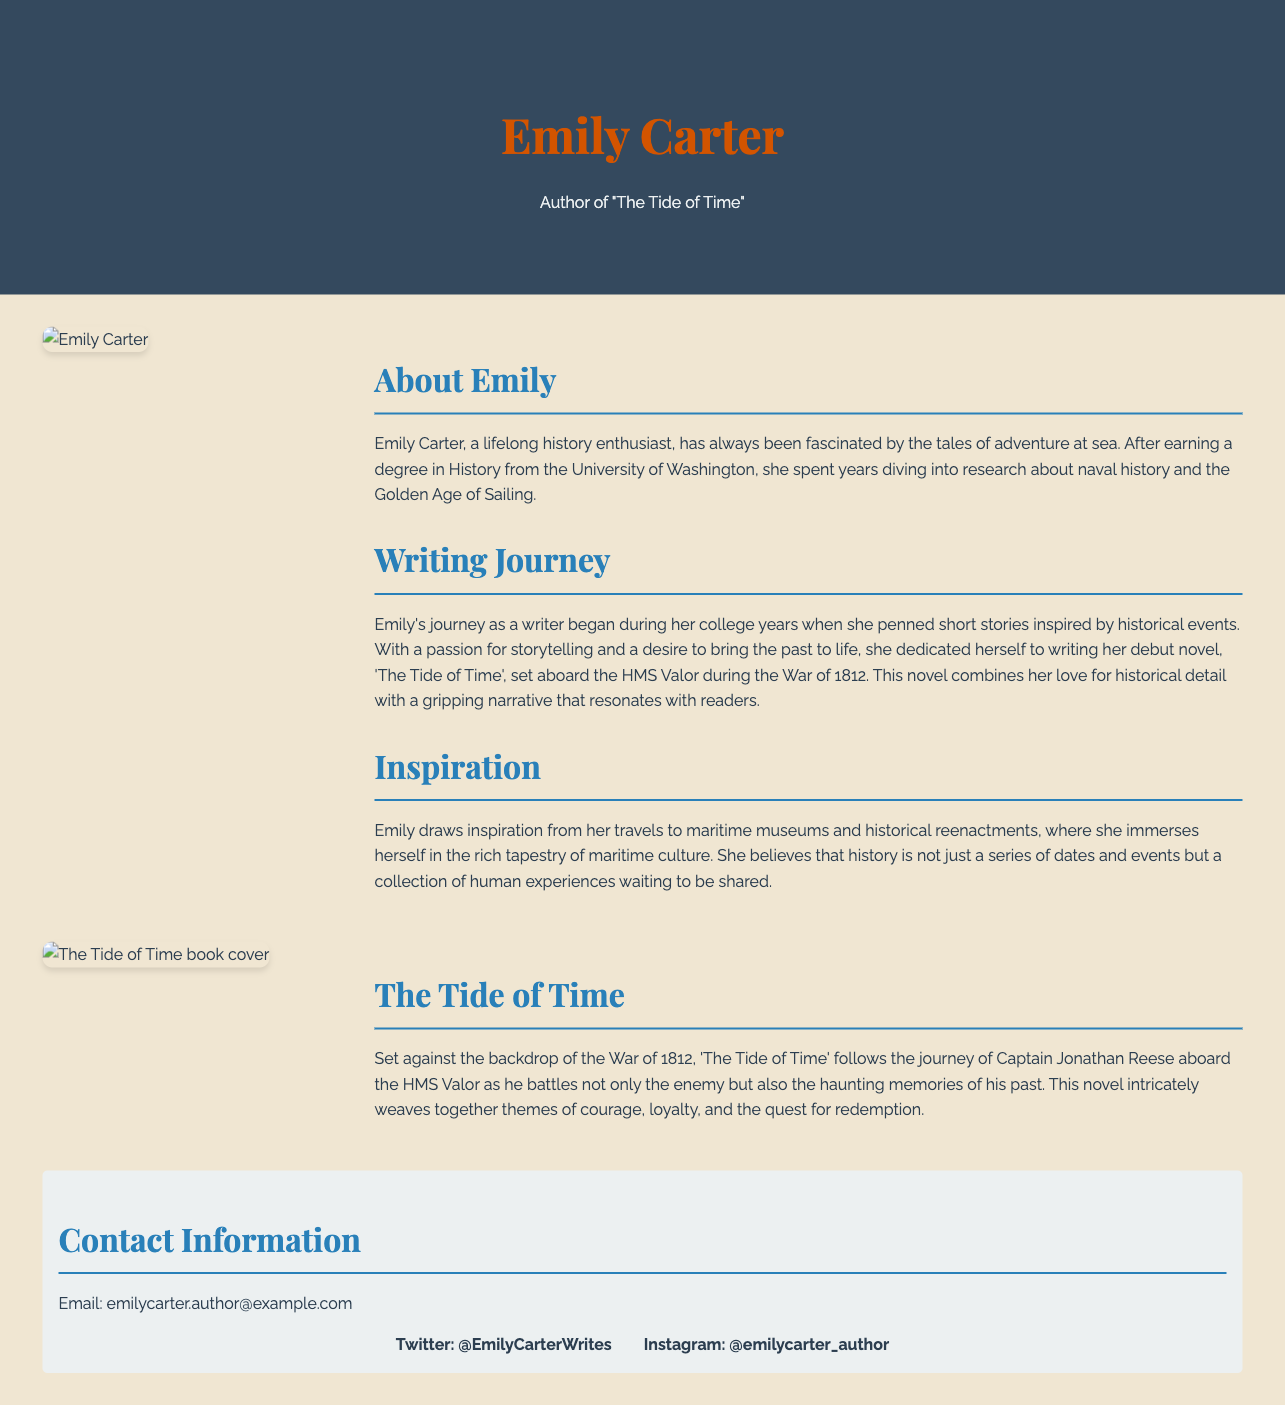What is the author's name? The author's name is prominently displayed in the header of the document.
Answer: Emily Carter What is the title of Emily Carter's novel? The title of the novel is mentioned in the header and in the author bio.
Answer: The Tide of Time What degree did Emily Carter earn? The document states Emily earned a degree in History.
Answer: History What historical ship is featured in the novel? The name of the historical ship is specified in the book description section.
Answer: HMS Valor In what year did Emily Carter begin her writing journey? The document mentions that Emily began her journey during her college years, suggesting a timeframe related to her education.
Answer: College years What theme does 'The Tide of Time' explore? The book description outlines several themes explored in the novel.
Answer: Courage, loyalty, and redemption What type of events does Emily draw inspiration from? Emily's sources of inspiration are mentioned in the inspiration section.
Answer: Historical reenactments What is the author's email address? The contact information section lists her email address.
Answer: emilycarter.author@example.com How many social media platforms are linked in the document? The social media section contains two links to different platforms.
Answer: Two 